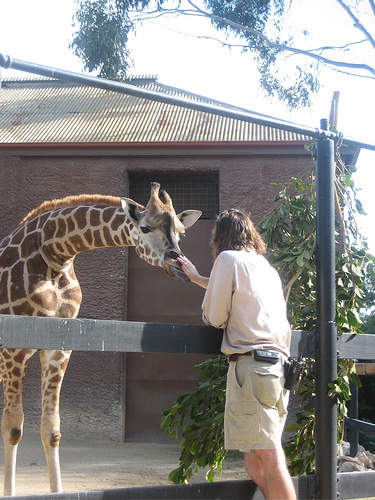Describe the objects in this image and their specific colors. I can see giraffe in white, gray, black, and tan tones and people in white, darkgray, and gray tones in this image. 